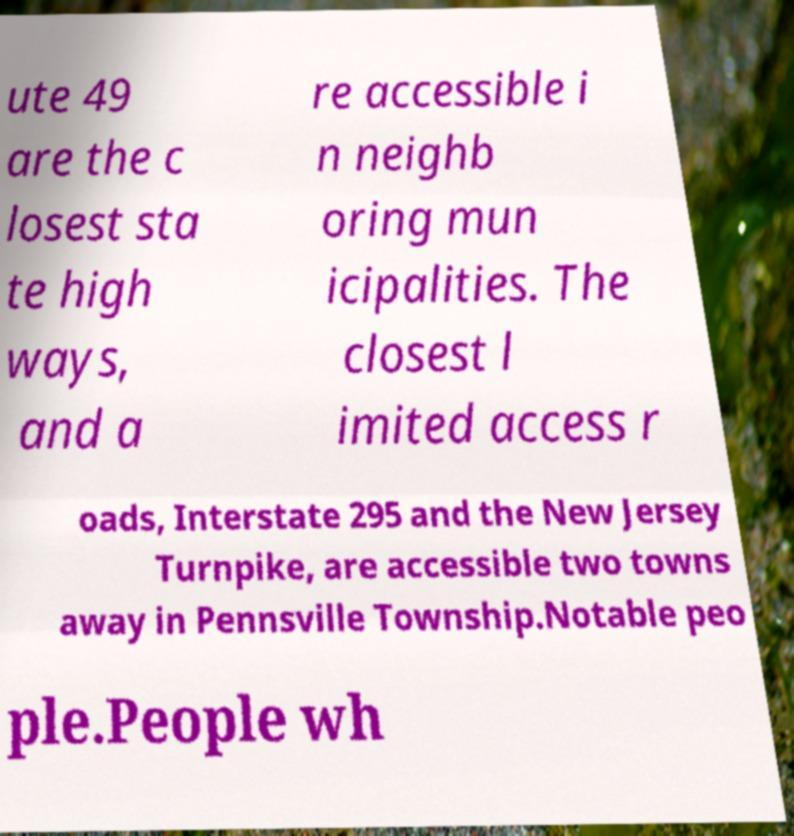I need the written content from this picture converted into text. Can you do that? ute 49 are the c losest sta te high ways, and a re accessible i n neighb oring mun icipalities. The closest l imited access r oads, Interstate 295 and the New Jersey Turnpike, are accessible two towns away in Pennsville Township.Notable peo ple.People wh 